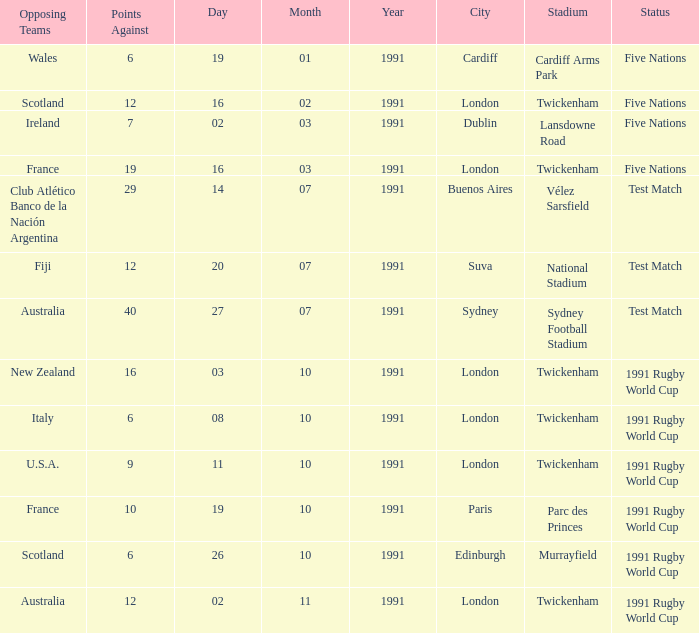What is Venue, when Status is "Test Match", and when Against is "12"? National Stadium , Suva. 